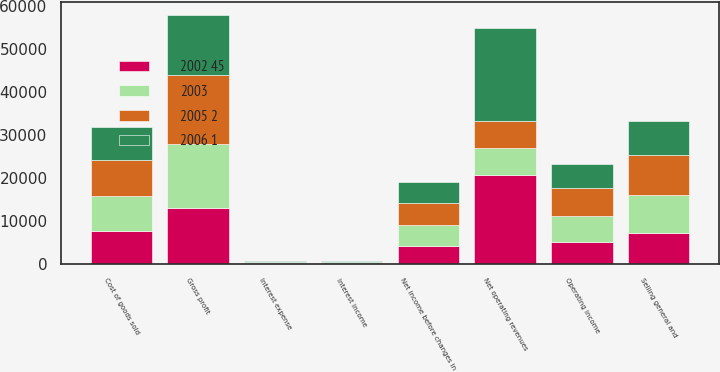Convert chart to OTSL. <chart><loc_0><loc_0><loc_500><loc_500><stacked_bar_chart><ecel><fcel>Net operating revenues<fcel>Cost of goods sold<fcel>Gross profit<fcel>Selling general and<fcel>Operating income<fcel>Interest income<fcel>Interest expense<fcel>Net income before changes in<nl><fcel>2005 2<fcel>6196.5<fcel>8164<fcel>15924<fcel>9431<fcel>6308<fcel>193<fcel>220<fcel>5080<nl><fcel>2003<fcel>6196.5<fcel>8195<fcel>14909<fcel>8739<fcel>6085<fcel>235<fcel>240<fcel>4872<nl><fcel>2006 1<fcel>21742<fcel>7674<fcel>14068<fcel>7890<fcel>5698<fcel>157<fcel>196<fcel>4847<nl><fcel>2002 45<fcel>20857<fcel>7776<fcel>13081<fcel>7287<fcel>5221<fcel>176<fcel>178<fcel>4347<nl></chart> 